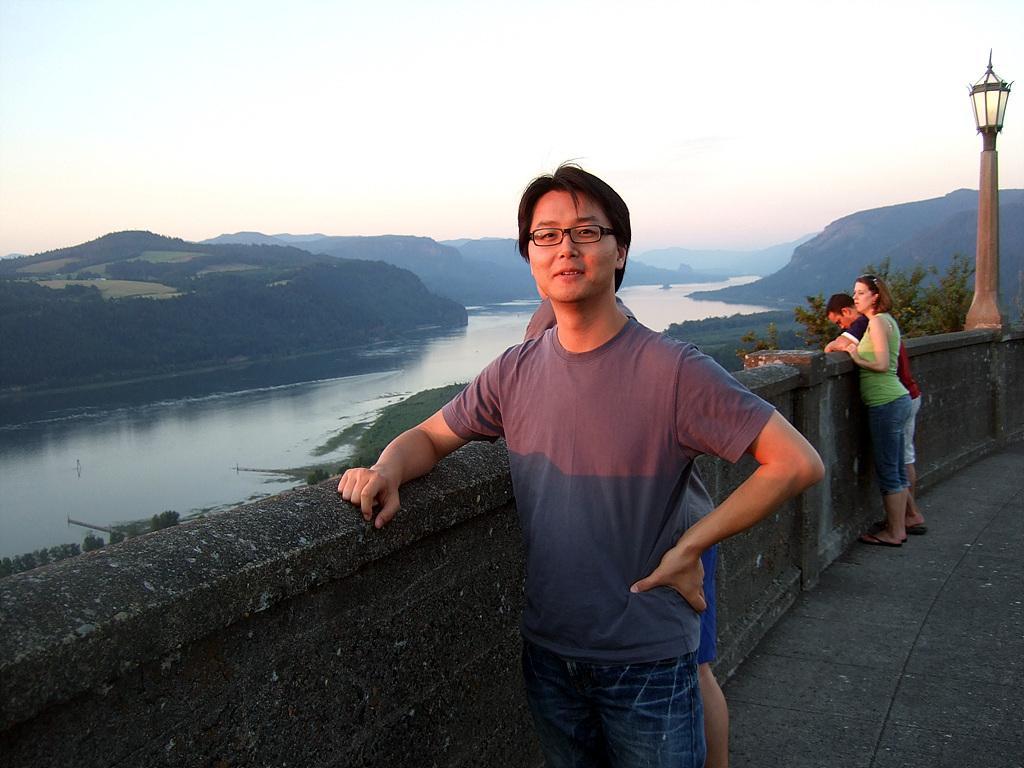Could you give a brief overview of what you see in this image? In this image I can see four persons are standing. In front the person is wearing brown color t-shirt and I can see the light pole. In the background I can see the water, few trees, mountains and the sky is in white and blue color. 